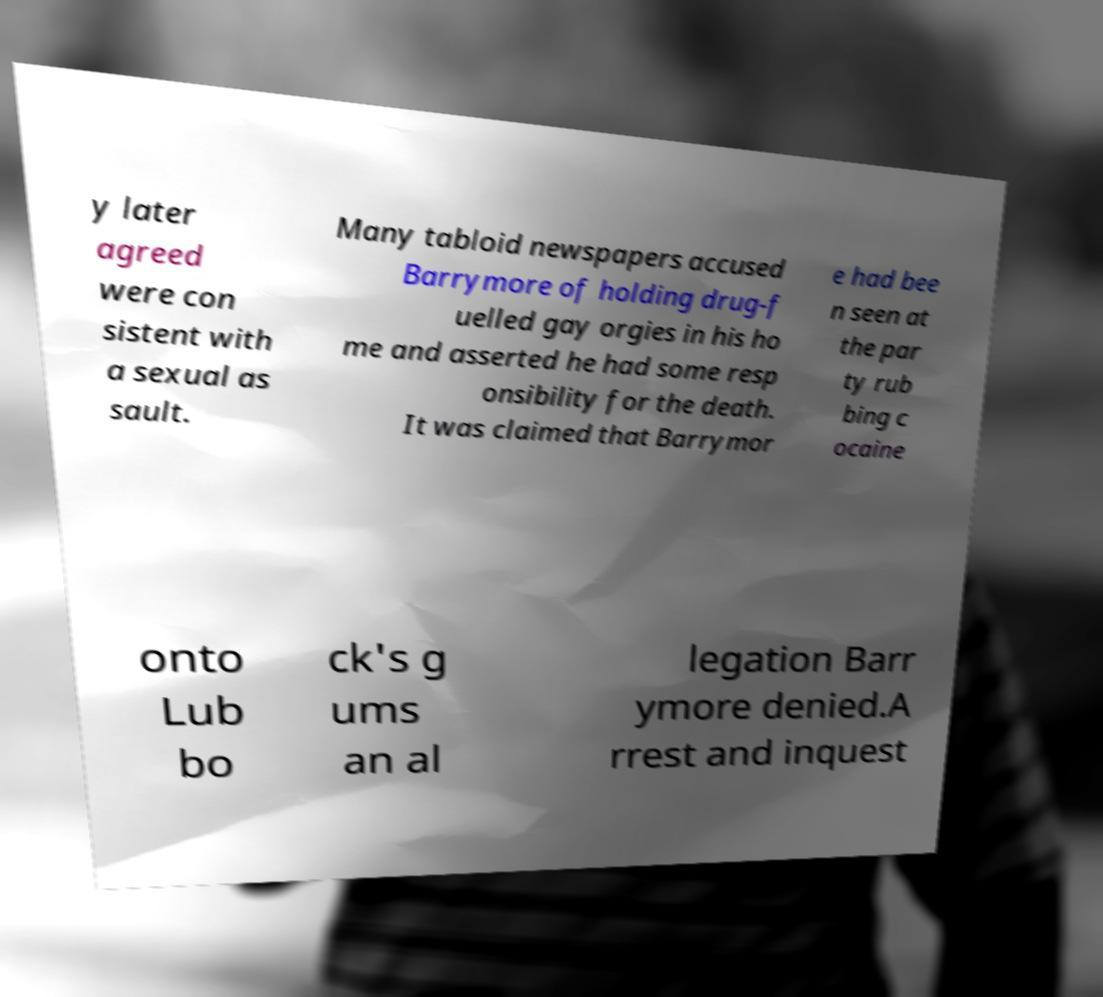There's text embedded in this image that I need extracted. Can you transcribe it verbatim? y later agreed were con sistent with a sexual as sault. Many tabloid newspapers accused Barrymore of holding drug-f uelled gay orgies in his ho me and asserted he had some resp onsibility for the death. It was claimed that Barrymor e had bee n seen at the par ty rub bing c ocaine onto Lub bo ck's g ums an al legation Barr ymore denied.A rrest and inquest 